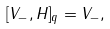<formula> <loc_0><loc_0><loc_500><loc_500>[ V _ { - } , H ] _ { q } = V _ { - } ,</formula> 